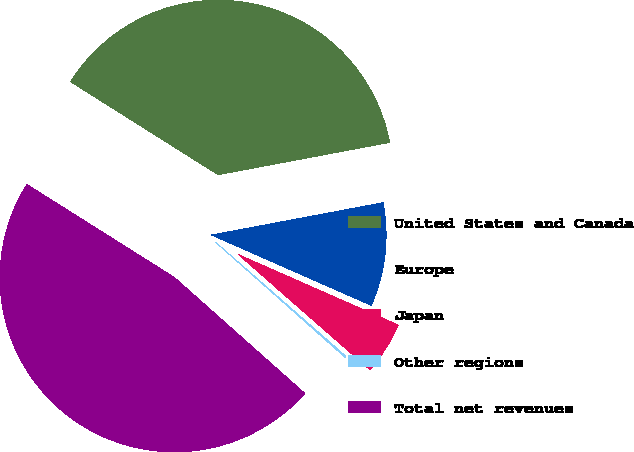Convert chart to OTSL. <chart><loc_0><loc_0><loc_500><loc_500><pie_chart><fcel>United States and Canada<fcel>Europe<fcel>Japan<fcel>Other regions<fcel>Total net revenues<nl><fcel>38.08%<fcel>9.57%<fcel>4.84%<fcel>0.12%<fcel>47.38%<nl></chart> 